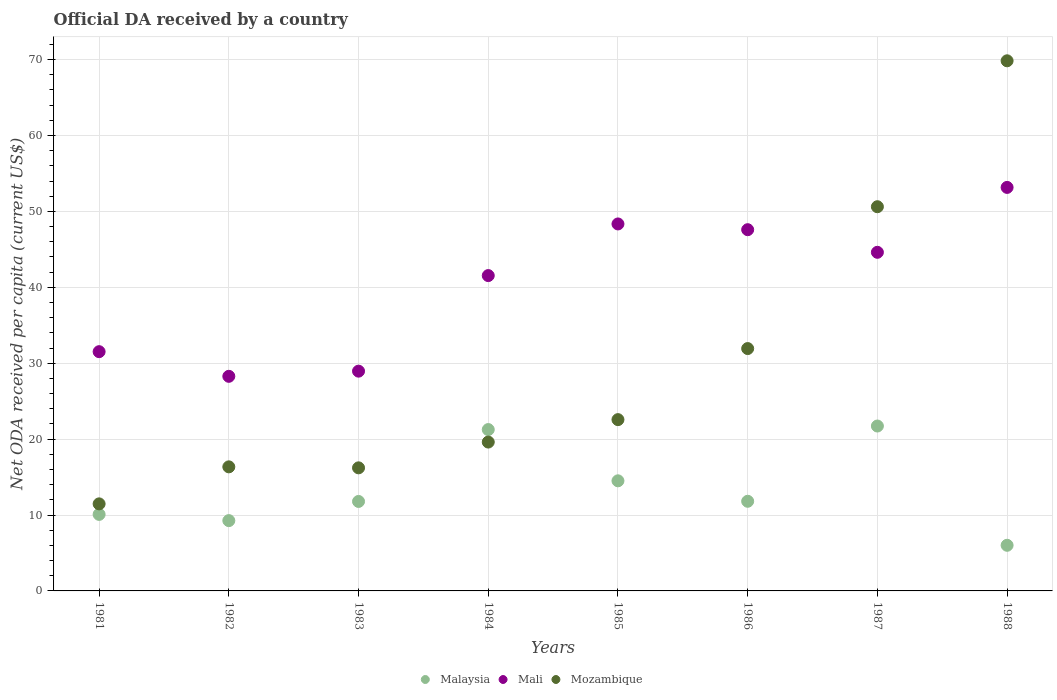Is the number of dotlines equal to the number of legend labels?
Your response must be concise. Yes. What is the ODA received in in Malaysia in 1985?
Ensure brevity in your answer.  14.51. Across all years, what is the maximum ODA received in in Mozambique?
Provide a short and direct response. 69.84. Across all years, what is the minimum ODA received in in Malaysia?
Keep it short and to the point. 6.01. What is the total ODA received in in Mozambique in the graph?
Provide a succinct answer. 238.59. What is the difference between the ODA received in in Malaysia in 1982 and that in 1987?
Provide a succinct answer. -12.46. What is the difference between the ODA received in in Mozambique in 1986 and the ODA received in in Mali in 1982?
Provide a succinct answer. 3.66. What is the average ODA received in in Malaysia per year?
Ensure brevity in your answer.  13.3. In the year 1988, what is the difference between the ODA received in in Mali and ODA received in in Malaysia?
Keep it short and to the point. 47.15. In how many years, is the ODA received in in Malaysia greater than 26 US$?
Your response must be concise. 0. What is the ratio of the ODA received in in Mali in 1982 to that in 1985?
Provide a succinct answer. 0.58. Is the difference between the ODA received in in Mali in 1982 and 1983 greater than the difference between the ODA received in in Malaysia in 1982 and 1983?
Make the answer very short. Yes. What is the difference between the highest and the second highest ODA received in in Malaysia?
Your response must be concise. 0.47. What is the difference between the highest and the lowest ODA received in in Malaysia?
Offer a very short reply. 15.71. In how many years, is the ODA received in in Mali greater than the average ODA received in in Mali taken over all years?
Keep it short and to the point. 5. Is it the case that in every year, the sum of the ODA received in in Mali and ODA received in in Mozambique  is greater than the ODA received in in Malaysia?
Make the answer very short. Yes. Is the ODA received in in Mozambique strictly greater than the ODA received in in Malaysia over the years?
Keep it short and to the point. No. Is the ODA received in in Mozambique strictly less than the ODA received in in Mali over the years?
Your answer should be compact. No. How many dotlines are there?
Keep it short and to the point. 3. Are the values on the major ticks of Y-axis written in scientific E-notation?
Provide a short and direct response. No. Where does the legend appear in the graph?
Provide a succinct answer. Bottom center. How many legend labels are there?
Provide a short and direct response. 3. What is the title of the graph?
Ensure brevity in your answer.  Official DA received by a country. Does "Greenland" appear as one of the legend labels in the graph?
Ensure brevity in your answer.  No. What is the label or title of the X-axis?
Give a very brief answer. Years. What is the label or title of the Y-axis?
Your answer should be very brief. Net ODA received per capita (current US$). What is the Net ODA received per capita (current US$) in Malaysia in 1981?
Your response must be concise. 10.08. What is the Net ODA received per capita (current US$) of Mali in 1981?
Make the answer very short. 31.52. What is the Net ODA received per capita (current US$) in Mozambique in 1981?
Give a very brief answer. 11.47. What is the Net ODA received per capita (current US$) in Malaysia in 1982?
Your answer should be compact. 9.26. What is the Net ODA received per capita (current US$) of Mali in 1982?
Keep it short and to the point. 28.27. What is the Net ODA received per capita (current US$) of Mozambique in 1982?
Give a very brief answer. 16.35. What is the Net ODA received per capita (current US$) of Malaysia in 1983?
Offer a terse response. 11.79. What is the Net ODA received per capita (current US$) of Mali in 1983?
Give a very brief answer. 28.95. What is the Net ODA received per capita (current US$) in Mozambique in 1983?
Make the answer very short. 16.21. What is the Net ODA received per capita (current US$) in Malaysia in 1984?
Ensure brevity in your answer.  21.26. What is the Net ODA received per capita (current US$) in Mali in 1984?
Make the answer very short. 41.54. What is the Net ODA received per capita (current US$) of Mozambique in 1984?
Keep it short and to the point. 19.61. What is the Net ODA received per capita (current US$) in Malaysia in 1985?
Your answer should be compact. 14.51. What is the Net ODA received per capita (current US$) of Mali in 1985?
Make the answer very short. 48.35. What is the Net ODA received per capita (current US$) in Mozambique in 1985?
Give a very brief answer. 22.57. What is the Net ODA received per capita (current US$) in Malaysia in 1986?
Provide a succinct answer. 11.81. What is the Net ODA received per capita (current US$) in Mali in 1986?
Your answer should be compact. 47.59. What is the Net ODA received per capita (current US$) in Mozambique in 1986?
Your answer should be compact. 31.93. What is the Net ODA received per capita (current US$) in Malaysia in 1987?
Make the answer very short. 21.72. What is the Net ODA received per capita (current US$) in Mali in 1987?
Make the answer very short. 44.61. What is the Net ODA received per capita (current US$) of Mozambique in 1987?
Give a very brief answer. 50.62. What is the Net ODA received per capita (current US$) of Malaysia in 1988?
Give a very brief answer. 6.01. What is the Net ODA received per capita (current US$) in Mali in 1988?
Ensure brevity in your answer.  53.16. What is the Net ODA received per capita (current US$) of Mozambique in 1988?
Provide a short and direct response. 69.84. Across all years, what is the maximum Net ODA received per capita (current US$) of Malaysia?
Offer a very short reply. 21.72. Across all years, what is the maximum Net ODA received per capita (current US$) in Mali?
Keep it short and to the point. 53.16. Across all years, what is the maximum Net ODA received per capita (current US$) in Mozambique?
Your answer should be very brief. 69.84. Across all years, what is the minimum Net ODA received per capita (current US$) of Malaysia?
Give a very brief answer. 6.01. Across all years, what is the minimum Net ODA received per capita (current US$) in Mali?
Ensure brevity in your answer.  28.27. Across all years, what is the minimum Net ODA received per capita (current US$) of Mozambique?
Make the answer very short. 11.47. What is the total Net ODA received per capita (current US$) of Malaysia in the graph?
Make the answer very short. 106.44. What is the total Net ODA received per capita (current US$) of Mali in the graph?
Provide a short and direct response. 324. What is the total Net ODA received per capita (current US$) in Mozambique in the graph?
Your response must be concise. 238.59. What is the difference between the Net ODA received per capita (current US$) of Malaysia in 1981 and that in 1982?
Provide a short and direct response. 0.82. What is the difference between the Net ODA received per capita (current US$) in Mali in 1981 and that in 1982?
Offer a very short reply. 3.25. What is the difference between the Net ODA received per capita (current US$) in Mozambique in 1981 and that in 1982?
Offer a terse response. -4.88. What is the difference between the Net ODA received per capita (current US$) in Malaysia in 1981 and that in 1983?
Provide a succinct answer. -1.71. What is the difference between the Net ODA received per capita (current US$) of Mali in 1981 and that in 1983?
Make the answer very short. 2.57. What is the difference between the Net ODA received per capita (current US$) in Mozambique in 1981 and that in 1983?
Your response must be concise. -4.75. What is the difference between the Net ODA received per capita (current US$) of Malaysia in 1981 and that in 1984?
Provide a succinct answer. -11.18. What is the difference between the Net ODA received per capita (current US$) in Mali in 1981 and that in 1984?
Offer a very short reply. -10.02. What is the difference between the Net ODA received per capita (current US$) in Mozambique in 1981 and that in 1984?
Keep it short and to the point. -8.14. What is the difference between the Net ODA received per capita (current US$) of Malaysia in 1981 and that in 1985?
Provide a succinct answer. -4.42. What is the difference between the Net ODA received per capita (current US$) in Mali in 1981 and that in 1985?
Make the answer very short. -16.83. What is the difference between the Net ODA received per capita (current US$) of Mozambique in 1981 and that in 1985?
Provide a succinct answer. -11.1. What is the difference between the Net ODA received per capita (current US$) in Malaysia in 1981 and that in 1986?
Provide a short and direct response. -1.73. What is the difference between the Net ODA received per capita (current US$) of Mali in 1981 and that in 1986?
Offer a terse response. -16.07. What is the difference between the Net ODA received per capita (current US$) of Mozambique in 1981 and that in 1986?
Offer a very short reply. -20.46. What is the difference between the Net ODA received per capita (current US$) in Malaysia in 1981 and that in 1987?
Keep it short and to the point. -11.64. What is the difference between the Net ODA received per capita (current US$) in Mali in 1981 and that in 1987?
Your answer should be compact. -13.09. What is the difference between the Net ODA received per capita (current US$) of Mozambique in 1981 and that in 1987?
Ensure brevity in your answer.  -39.15. What is the difference between the Net ODA received per capita (current US$) of Malaysia in 1981 and that in 1988?
Your answer should be compact. 4.07. What is the difference between the Net ODA received per capita (current US$) in Mali in 1981 and that in 1988?
Offer a terse response. -21.64. What is the difference between the Net ODA received per capita (current US$) in Mozambique in 1981 and that in 1988?
Your answer should be very brief. -58.37. What is the difference between the Net ODA received per capita (current US$) of Malaysia in 1982 and that in 1983?
Offer a very short reply. -2.52. What is the difference between the Net ODA received per capita (current US$) in Mali in 1982 and that in 1983?
Offer a terse response. -0.68. What is the difference between the Net ODA received per capita (current US$) in Mozambique in 1982 and that in 1983?
Your response must be concise. 0.13. What is the difference between the Net ODA received per capita (current US$) of Malaysia in 1982 and that in 1984?
Provide a succinct answer. -11.99. What is the difference between the Net ODA received per capita (current US$) in Mali in 1982 and that in 1984?
Your response must be concise. -13.27. What is the difference between the Net ODA received per capita (current US$) in Mozambique in 1982 and that in 1984?
Offer a terse response. -3.27. What is the difference between the Net ODA received per capita (current US$) of Malaysia in 1982 and that in 1985?
Make the answer very short. -5.24. What is the difference between the Net ODA received per capita (current US$) of Mali in 1982 and that in 1985?
Provide a short and direct response. -20.07. What is the difference between the Net ODA received per capita (current US$) of Mozambique in 1982 and that in 1985?
Give a very brief answer. -6.22. What is the difference between the Net ODA received per capita (current US$) of Malaysia in 1982 and that in 1986?
Ensure brevity in your answer.  -2.55. What is the difference between the Net ODA received per capita (current US$) in Mali in 1982 and that in 1986?
Your answer should be very brief. -19.32. What is the difference between the Net ODA received per capita (current US$) of Mozambique in 1982 and that in 1986?
Your answer should be compact. -15.58. What is the difference between the Net ODA received per capita (current US$) of Malaysia in 1982 and that in 1987?
Offer a very short reply. -12.46. What is the difference between the Net ODA received per capita (current US$) of Mali in 1982 and that in 1987?
Your response must be concise. -16.34. What is the difference between the Net ODA received per capita (current US$) of Mozambique in 1982 and that in 1987?
Provide a succinct answer. -34.27. What is the difference between the Net ODA received per capita (current US$) in Malaysia in 1982 and that in 1988?
Provide a short and direct response. 3.25. What is the difference between the Net ODA received per capita (current US$) of Mali in 1982 and that in 1988?
Your answer should be very brief. -24.89. What is the difference between the Net ODA received per capita (current US$) in Mozambique in 1982 and that in 1988?
Ensure brevity in your answer.  -53.49. What is the difference between the Net ODA received per capita (current US$) of Malaysia in 1983 and that in 1984?
Keep it short and to the point. -9.47. What is the difference between the Net ODA received per capita (current US$) in Mali in 1983 and that in 1984?
Offer a terse response. -12.59. What is the difference between the Net ODA received per capita (current US$) of Mozambique in 1983 and that in 1984?
Give a very brief answer. -3.4. What is the difference between the Net ODA received per capita (current US$) of Malaysia in 1983 and that in 1985?
Your answer should be compact. -2.72. What is the difference between the Net ODA received per capita (current US$) in Mali in 1983 and that in 1985?
Provide a succinct answer. -19.39. What is the difference between the Net ODA received per capita (current US$) of Mozambique in 1983 and that in 1985?
Make the answer very short. -6.35. What is the difference between the Net ODA received per capita (current US$) of Malaysia in 1983 and that in 1986?
Keep it short and to the point. -0.02. What is the difference between the Net ODA received per capita (current US$) of Mali in 1983 and that in 1986?
Keep it short and to the point. -18.64. What is the difference between the Net ODA received per capita (current US$) of Mozambique in 1983 and that in 1986?
Your answer should be compact. -15.71. What is the difference between the Net ODA received per capita (current US$) of Malaysia in 1983 and that in 1987?
Offer a very short reply. -9.94. What is the difference between the Net ODA received per capita (current US$) of Mali in 1983 and that in 1987?
Keep it short and to the point. -15.66. What is the difference between the Net ODA received per capita (current US$) in Mozambique in 1983 and that in 1987?
Provide a short and direct response. -34.4. What is the difference between the Net ODA received per capita (current US$) in Malaysia in 1983 and that in 1988?
Offer a terse response. 5.78. What is the difference between the Net ODA received per capita (current US$) of Mali in 1983 and that in 1988?
Offer a terse response. -24.21. What is the difference between the Net ODA received per capita (current US$) in Mozambique in 1983 and that in 1988?
Your answer should be very brief. -53.63. What is the difference between the Net ODA received per capita (current US$) of Malaysia in 1984 and that in 1985?
Your response must be concise. 6.75. What is the difference between the Net ODA received per capita (current US$) in Mali in 1984 and that in 1985?
Offer a terse response. -6.8. What is the difference between the Net ODA received per capita (current US$) in Mozambique in 1984 and that in 1985?
Your answer should be very brief. -2.96. What is the difference between the Net ODA received per capita (current US$) of Malaysia in 1984 and that in 1986?
Make the answer very short. 9.45. What is the difference between the Net ODA received per capita (current US$) of Mali in 1984 and that in 1986?
Provide a short and direct response. -6.05. What is the difference between the Net ODA received per capita (current US$) of Mozambique in 1984 and that in 1986?
Make the answer very short. -12.32. What is the difference between the Net ODA received per capita (current US$) of Malaysia in 1984 and that in 1987?
Make the answer very short. -0.47. What is the difference between the Net ODA received per capita (current US$) in Mali in 1984 and that in 1987?
Your response must be concise. -3.07. What is the difference between the Net ODA received per capita (current US$) of Mozambique in 1984 and that in 1987?
Your response must be concise. -31. What is the difference between the Net ODA received per capita (current US$) of Malaysia in 1984 and that in 1988?
Provide a short and direct response. 15.24. What is the difference between the Net ODA received per capita (current US$) of Mali in 1984 and that in 1988?
Your answer should be very brief. -11.62. What is the difference between the Net ODA received per capita (current US$) of Mozambique in 1984 and that in 1988?
Provide a short and direct response. -50.23. What is the difference between the Net ODA received per capita (current US$) of Malaysia in 1985 and that in 1986?
Ensure brevity in your answer.  2.7. What is the difference between the Net ODA received per capita (current US$) in Mali in 1985 and that in 1986?
Your response must be concise. 0.76. What is the difference between the Net ODA received per capita (current US$) of Mozambique in 1985 and that in 1986?
Your answer should be compact. -9.36. What is the difference between the Net ODA received per capita (current US$) of Malaysia in 1985 and that in 1987?
Keep it short and to the point. -7.22. What is the difference between the Net ODA received per capita (current US$) in Mali in 1985 and that in 1987?
Keep it short and to the point. 3.74. What is the difference between the Net ODA received per capita (current US$) of Mozambique in 1985 and that in 1987?
Ensure brevity in your answer.  -28.05. What is the difference between the Net ODA received per capita (current US$) in Malaysia in 1985 and that in 1988?
Offer a terse response. 8.49. What is the difference between the Net ODA received per capita (current US$) in Mali in 1985 and that in 1988?
Keep it short and to the point. -4.81. What is the difference between the Net ODA received per capita (current US$) of Mozambique in 1985 and that in 1988?
Offer a very short reply. -47.27. What is the difference between the Net ODA received per capita (current US$) in Malaysia in 1986 and that in 1987?
Offer a terse response. -9.91. What is the difference between the Net ODA received per capita (current US$) of Mali in 1986 and that in 1987?
Make the answer very short. 2.98. What is the difference between the Net ODA received per capita (current US$) of Mozambique in 1986 and that in 1987?
Provide a short and direct response. -18.69. What is the difference between the Net ODA received per capita (current US$) in Malaysia in 1986 and that in 1988?
Provide a succinct answer. 5.8. What is the difference between the Net ODA received per capita (current US$) in Mali in 1986 and that in 1988?
Ensure brevity in your answer.  -5.57. What is the difference between the Net ODA received per capita (current US$) of Mozambique in 1986 and that in 1988?
Ensure brevity in your answer.  -37.91. What is the difference between the Net ODA received per capita (current US$) in Malaysia in 1987 and that in 1988?
Your answer should be compact. 15.71. What is the difference between the Net ODA received per capita (current US$) in Mali in 1987 and that in 1988?
Give a very brief answer. -8.55. What is the difference between the Net ODA received per capita (current US$) of Mozambique in 1987 and that in 1988?
Provide a short and direct response. -19.22. What is the difference between the Net ODA received per capita (current US$) of Malaysia in 1981 and the Net ODA received per capita (current US$) of Mali in 1982?
Keep it short and to the point. -18.19. What is the difference between the Net ODA received per capita (current US$) of Malaysia in 1981 and the Net ODA received per capita (current US$) of Mozambique in 1982?
Make the answer very short. -6.26. What is the difference between the Net ODA received per capita (current US$) of Mali in 1981 and the Net ODA received per capita (current US$) of Mozambique in 1982?
Offer a very short reply. 15.17. What is the difference between the Net ODA received per capita (current US$) of Malaysia in 1981 and the Net ODA received per capita (current US$) of Mali in 1983?
Provide a succinct answer. -18.87. What is the difference between the Net ODA received per capita (current US$) in Malaysia in 1981 and the Net ODA received per capita (current US$) in Mozambique in 1983?
Your answer should be compact. -6.13. What is the difference between the Net ODA received per capita (current US$) in Mali in 1981 and the Net ODA received per capita (current US$) in Mozambique in 1983?
Provide a short and direct response. 15.31. What is the difference between the Net ODA received per capita (current US$) in Malaysia in 1981 and the Net ODA received per capita (current US$) in Mali in 1984?
Ensure brevity in your answer.  -31.46. What is the difference between the Net ODA received per capita (current US$) in Malaysia in 1981 and the Net ODA received per capita (current US$) in Mozambique in 1984?
Your answer should be very brief. -9.53. What is the difference between the Net ODA received per capita (current US$) in Mali in 1981 and the Net ODA received per capita (current US$) in Mozambique in 1984?
Your answer should be very brief. 11.91. What is the difference between the Net ODA received per capita (current US$) of Malaysia in 1981 and the Net ODA received per capita (current US$) of Mali in 1985?
Make the answer very short. -38.27. What is the difference between the Net ODA received per capita (current US$) of Malaysia in 1981 and the Net ODA received per capita (current US$) of Mozambique in 1985?
Give a very brief answer. -12.48. What is the difference between the Net ODA received per capita (current US$) of Mali in 1981 and the Net ODA received per capita (current US$) of Mozambique in 1985?
Offer a very short reply. 8.95. What is the difference between the Net ODA received per capita (current US$) in Malaysia in 1981 and the Net ODA received per capita (current US$) in Mali in 1986?
Your answer should be very brief. -37.51. What is the difference between the Net ODA received per capita (current US$) in Malaysia in 1981 and the Net ODA received per capita (current US$) in Mozambique in 1986?
Your response must be concise. -21.85. What is the difference between the Net ODA received per capita (current US$) of Mali in 1981 and the Net ODA received per capita (current US$) of Mozambique in 1986?
Offer a terse response. -0.41. What is the difference between the Net ODA received per capita (current US$) in Malaysia in 1981 and the Net ODA received per capita (current US$) in Mali in 1987?
Provide a short and direct response. -34.53. What is the difference between the Net ODA received per capita (current US$) of Malaysia in 1981 and the Net ODA received per capita (current US$) of Mozambique in 1987?
Offer a very short reply. -40.53. What is the difference between the Net ODA received per capita (current US$) of Mali in 1981 and the Net ODA received per capita (current US$) of Mozambique in 1987?
Your answer should be very brief. -19.1. What is the difference between the Net ODA received per capita (current US$) of Malaysia in 1981 and the Net ODA received per capita (current US$) of Mali in 1988?
Make the answer very short. -43.08. What is the difference between the Net ODA received per capita (current US$) in Malaysia in 1981 and the Net ODA received per capita (current US$) in Mozambique in 1988?
Your answer should be compact. -59.76. What is the difference between the Net ODA received per capita (current US$) of Mali in 1981 and the Net ODA received per capita (current US$) of Mozambique in 1988?
Offer a very short reply. -38.32. What is the difference between the Net ODA received per capita (current US$) in Malaysia in 1982 and the Net ODA received per capita (current US$) in Mali in 1983?
Your answer should be very brief. -19.69. What is the difference between the Net ODA received per capita (current US$) in Malaysia in 1982 and the Net ODA received per capita (current US$) in Mozambique in 1983?
Keep it short and to the point. -6.95. What is the difference between the Net ODA received per capita (current US$) of Mali in 1982 and the Net ODA received per capita (current US$) of Mozambique in 1983?
Your response must be concise. 12.06. What is the difference between the Net ODA received per capita (current US$) of Malaysia in 1982 and the Net ODA received per capita (current US$) of Mali in 1984?
Your response must be concise. -32.28. What is the difference between the Net ODA received per capita (current US$) of Malaysia in 1982 and the Net ODA received per capita (current US$) of Mozambique in 1984?
Give a very brief answer. -10.35. What is the difference between the Net ODA received per capita (current US$) in Mali in 1982 and the Net ODA received per capita (current US$) in Mozambique in 1984?
Ensure brevity in your answer.  8.66. What is the difference between the Net ODA received per capita (current US$) in Malaysia in 1982 and the Net ODA received per capita (current US$) in Mali in 1985?
Offer a terse response. -39.08. What is the difference between the Net ODA received per capita (current US$) of Malaysia in 1982 and the Net ODA received per capita (current US$) of Mozambique in 1985?
Offer a very short reply. -13.3. What is the difference between the Net ODA received per capita (current US$) of Mali in 1982 and the Net ODA received per capita (current US$) of Mozambique in 1985?
Your answer should be compact. 5.71. What is the difference between the Net ODA received per capita (current US$) of Malaysia in 1982 and the Net ODA received per capita (current US$) of Mali in 1986?
Offer a very short reply. -38.33. What is the difference between the Net ODA received per capita (current US$) in Malaysia in 1982 and the Net ODA received per capita (current US$) in Mozambique in 1986?
Ensure brevity in your answer.  -22.67. What is the difference between the Net ODA received per capita (current US$) of Mali in 1982 and the Net ODA received per capita (current US$) of Mozambique in 1986?
Provide a short and direct response. -3.66. What is the difference between the Net ODA received per capita (current US$) in Malaysia in 1982 and the Net ODA received per capita (current US$) in Mali in 1987?
Provide a short and direct response. -35.35. What is the difference between the Net ODA received per capita (current US$) in Malaysia in 1982 and the Net ODA received per capita (current US$) in Mozambique in 1987?
Your response must be concise. -41.35. What is the difference between the Net ODA received per capita (current US$) in Mali in 1982 and the Net ODA received per capita (current US$) in Mozambique in 1987?
Your answer should be compact. -22.34. What is the difference between the Net ODA received per capita (current US$) in Malaysia in 1982 and the Net ODA received per capita (current US$) in Mali in 1988?
Provide a short and direct response. -43.9. What is the difference between the Net ODA received per capita (current US$) in Malaysia in 1982 and the Net ODA received per capita (current US$) in Mozambique in 1988?
Ensure brevity in your answer.  -60.58. What is the difference between the Net ODA received per capita (current US$) of Mali in 1982 and the Net ODA received per capita (current US$) of Mozambique in 1988?
Provide a short and direct response. -41.57. What is the difference between the Net ODA received per capita (current US$) of Malaysia in 1983 and the Net ODA received per capita (current US$) of Mali in 1984?
Your answer should be compact. -29.76. What is the difference between the Net ODA received per capita (current US$) in Malaysia in 1983 and the Net ODA received per capita (current US$) in Mozambique in 1984?
Offer a very short reply. -7.82. What is the difference between the Net ODA received per capita (current US$) in Mali in 1983 and the Net ODA received per capita (current US$) in Mozambique in 1984?
Your answer should be very brief. 9.34. What is the difference between the Net ODA received per capita (current US$) of Malaysia in 1983 and the Net ODA received per capita (current US$) of Mali in 1985?
Provide a short and direct response. -36.56. What is the difference between the Net ODA received per capita (current US$) in Malaysia in 1983 and the Net ODA received per capita (current US$) in Mozambique in 1985?
Keep it short and to the point. -10.78. What is the difference between the Net ODA received per capita (current US$) in Mali in 1983 and the Net ODA received per capita (current US$) in Mozambique in 1985?
Your answer should be compact. 6.39. What is the difference between the Net ODA received per capita (current US$) of Malaysia in 1983 and the Net ODA received per capita (current US$) of Mali in 1986?
Offer a terse response. -35.8. What is the difference between the Net ODA received per capita (current US$) of Malaysia in 1983 and the Net ODA received per capita (current US$) of Mozambique in 1986?
Make the answer very short. -20.14. What is the difference between the Net ODA received per capita (current US$) in Mali in 1983 and the Net ODA received per capita (current US$) in Mozambique in 1986?
Make the answer very short. -2.98. What is the difference between the Net ODA received per capita (current US$) in Malaysia in 1983 and the Net ODA received per capita (current US$) in Mali in 1987?
Offer a very short reply. -32.82. What is the difference between the Net ODA received per capita (current US$) of Malaysia in 1983 and the Net ODA received per capita (current US$) of Mozambique in 1987?
Provide a short and direct response. -38.83. What is the difference between the Net ODA received per capita (current US$) of Mali in 1983 and the Net ODA received per capita (current US$) of Mozambique in 1987?
Offer a very short reply. -21.66. What is the difference between the Net ODA received per capita (current US$) in Malaysia in 1983 and the Net ODA received per capita (current US$) in Mali in 1988?
Ensure brevity in your answer.  -41.37. What is the difference between the Net ODA received per capita (current US$) in Malaysia in 1983 and the Net ODA received per capita (current US$) in Mozambique in 1988?
Your answer should be compact. -58.05. What is the difference between the Net ODA received per capita (current US$) in Mali in 1983 and the Net ODA received per capita (current US$) in Mozambique in 1988?
Offer a very short reply. -40.89. What is the difference between the Net ODA received per capita (current US$) of Malaysia in 1984 and the Net ODA received per capita (current US$) of Mali in 1985?
Ensure brevity in your answer.  -27.09. What is the difference between the Net ODA received per capita (current US$) in Malaysia in 1984 and the Net ODA received per capita (current US$) in Mozambique in 1985?
Ensure brevity in your answer.  -1.31. What is the difference between the Net ODA received per capita (current US$) of Mali in 1984 and the Net ODA received per capita (current US$) of Mozambique in 1985?
Your response must be concise. 18.98. What is the difference between the Net ODA received per capita (current US$) of Malaysia in 1984 and the Net ODA received per capita (current US$) of Mali in 1986?
Provide a short and direct response. -26.33. What is the difference between the Net ODA received per capita (current US$) of Malaysia in 1984 and the Net ODA received per capita (current US$) of Mozambique in 1986?
Ensure brevity in your answer.  -10.67. What is the difference between the Net ODA received per capita (current US$) in Mali in 1984 and the Net ODA received per capita (current US$) in Mozambique in 1986?
Offer a very short reply. 9.61. What is the difference between the Net ODA received per capita (current US$) of Malaysia in 1984 and the Net ODA received per capita (current US$) of Mali in 1987?
Provide a short and direct response. -23.35. What is the difference between the Net ODA received per capita (current US$) of Malaysia in 1984 and the Net ODA received per capita (current US$) of Mozambique in 1987?
Your response must be concise. -29.36. What is the difference between the Net ODA received per capita (current US$) in Mali in 1984 and the Net ODA received per capita (current US$) in Mozambique in 1987?
Your answer should be compact. -9.07. What is the difference between the Net ODA received per capita (current US$) of Malaysia in 1984 and the Net ODA received per capita (current US$) of Mali in 1988?
Provide a succinct answer. -31.9. What is the difference between the Net ODA received per capita (current US$) of Malaysia in 1984 and the Net ODA received per capita (current US$) of Mozambique in 1988?
Make the answer very short. -48.58. What is the difference between the Net ODA received per capita (current US$) of Mali in 1984 and the Net ODA received per capita (current US$) of Mozambique in 1988?
Ensure brevity in your answer.  -28.3. What is the difference between the Net ODA received per capita (current US$) of Malaysia in 1985 and the Net ODA received per capita (current US$) of Mali in 1986?
Your answer should be compact. -33.08. What is the difference between the Net ODA received per capita (current US$) in Malaysia in 1985 and the Net ODA received per capita (current US$) in Mozambique in 1986?
Your answer should be compact. -17.42. What is the difference between the Net ODA received per capita (current US$) in Mali in 1985 and the Net ODA received per capita (current US$) in Mozambique in 1986?
Provide a short and direct response. 16.42. What is the difference between the Net ODA received per capita (current US$) of Malaysia in 1985 and the Net ODA received per capita (current US$) of Mali in 1987?
Provide a succinct answer. -30.11. What is the difference between the Net ODA received per capita (current US$) in Malaysia in 1985 and the Net ODA received per capita (current US$) in Mozambique in 1987?
Provide a short and direct response. -36.11. What is the difference between the Net ODA received per capita (current US$) in Mali in 1985 and the Net ODA received per capita (current US$) in Mozambique in 1987?
Give a very brief answer. -2.27. What is the difference between the Net ODA received per capita (current US$) of Malaysia in 1985 and the Net ODA received per capita (current US$) of Mali in 1988?
Provide a short and direct response. -38.65. What is the difference between the Net ODA received per capita (current US$) in Malaysia in 1985 and the Net ODA received per capita (current US$) in Mozambique in 1988?
Keep it short and to the point. -55.33. What is the difference between the Net ODA received per capita (current US$) in Mali in 1985 and the Net ODA received per capita (current US$) in Mozambique in 1988?
Provide a short and direct response. -21.49. What is the difference between the Net ODA received per capita (current US$) in Malaysia in 1986 and the Net ODA received per capita (current US$) in Mali in 1987?
Your answer should be compact. -32.8. What is the difference between the Net ODA received per capita (current US$) in Malaysia in 1986 and the Net ODA received per capita (current US$) in Mozambique in 1987?
Provide a short and direct response. -38.81. What is the difference between the Net ODA received per capita (current US$) of Mali in 1986 and the Net ODA received per capita (current US$) of Mozambique in 1987?
Make the answer very short. -3.03. What is the difference between the Net ODA received per capita (current US$) of Malaysia in 1986 and the Net ODA received per capita (current US$) of Mali in 1988?
Make the answer very short. -41.35. What is the difference between the Net ODA received per capita (current US$) in Malaysia in 1986 and the Net ODA received per capita (current US$) in Mozambique in 1988?
Give a very brief answer. -58.03. What is the difference between the Net ODA received per capita (current US$) in Mali in 1986 and the Net ODA received per capita (current US$) in Mozambique in 1988?
Make the answer very short. -22.25. What is the difference between the Net ODA received per capita (current US$) in Malaysia in 1987 and the Net ODA received per capita (current US$) in Mali in 1988?
Give a very brief answer. -31.44. What is the difference between the Net ODA received per capita (current US$) of Malaysia in 1987 and the Net ODA received per capita (current US$) of Mozambique in 1988?
Your answer should be compact. -48.12. What is the difference between the Net ODA received per capita (current US$) in Mali in 1987 and the Net ODA received per capita (current US$) in Mozambique in 1988?
Ensure brevity in your answer.  -25.23. What is the average Net ODA received per capita (current US$) in Malaysia per year?
Your response must be concise. 13.3. What is the average Net ODA received per capita (current US$) of Mali per year?
Your answer should be compact. 40.5. What is the average Net ODA received per capita (current US$) of Mozambique per year?
Provide a short and direct response. 29.82. In the year 1981, what is the difference between the Net ODA received per capita (current US$) of Malaysia and Net ODA received per capita (current US$) of Mali?
Ensure brevity in your answer.  -21.44. In the year 1981, what is the difference between the Net ODA received per capita (current US$) in Malaysia and Net ODA received per capita (current US$) in Mozambique?
Ensure brevity in your answer.  -1.39. In the year 1981, what is the difference between the Net ODA received per capita (current US$) of Mali and Net ODA received per capita (current US$) of Mozambique?
Offer a terse response. 20.05. In the year 1982, what is the difference between the Net ODA received per capita (current US$) of Malaysia and Net ODA received per capita (current US$) of Mali?
Keep it short and to the point. -19.01. In the year 1982, what is the difference between the Net ODA received per capita (current US$) in Malaysia and Net ODA received per capita (current US$) in Mozambique?
Provide a succinct answer. -7.08. In the year 1982, what is the difference between the Net ODA received per capita (current US$) in Mali and Net ODA received per capita (current US$) in Mozambique?
Make the answer very short. 11.93. In the year 1983, what is the difference between the Net ODA received per capita (current US$) of Malaysia and Net ODA received per capita (current US$) of Mali?
Make the answer very short. -17.16. In the year 1983, what is the difference between the Net ODA received per capita (current US$) of Malaysia and Net ODA received per capita (current US$) of Mozambique?
Ensure brevity in your answer.  -4.43. In the year 1983, what is the difference between the Net ODA received per capita (current US$) of Mali and Net ODA received per capita (current US$) of Mozambique?
Your answer should be compact. 12.74. In the year 1984, what is the difference between the Net ODA received per capita (current US$) of Malaysia and Net ODA received per capita (current US$) of Mali?
Your answer should be very brief. -20.29. In the year 1984, what is the difference between the Net ODA received per capita (current US$) of Malaysia and Net ODA received per capita (current US$) of Mozambique?
Keep it short and to the point. 1.65. In the year 1984, what is the difference between the Net ODA received per capita (current US$) of Mali and Net ODA received per capita (current US$) of Mozambique?
Offer a terse response. 21.93. In the year 1985, what is the difference between the Net ODA received per capita (current US$) in Malaysia and Net ODA received per capita (current US$) in Mali?
Keep it short and to the point. -33.84. In the year 1985, what is the difference between the Net ODA received per capita (current US$) of Malaysia and Net ODA received per capita (current US$) of Mozambique?
Keep it short and to the point. -8.06. In the year 1985, what is the difference between the Net ODA received per capita (current US$) of Mali and Net ODA received per capita (current US$) of Mozambique?
Give a very brief answer. 25.78. In the year 1986, what is the difference between the Net ODA received per capita (current US$) in Malaysia and Net ODA received per capita (current US$) in Mali?
Provide a succinct answer. -35.78. In the year 1986, what is the difference between the Net ODA received per capita (current US$) in Malaysia and Net ODA received per capita (current US$) in Mozambique?
Your answer should be compact. -20.12. In the year 1986, what is the difference between the Net ODA received per capita (current US$) of Mali and Net ODA received per capita (current US$) of Mozambique?
Offer a terse response. 15.66. In the year 1987, what is the difference between the Net ODA received per capita (current US$) of Malaysia and Net ODA received per capita (current US$) of Mali?
Make the answer very short. -22.89. In the year 1987, what is the difference between the Net ODA received per capita (current US$) of Malaysia and Net ODA received per capita (current US$) of Mozambique?
Provide a succinct answer. -28.89. In the year 1987, what is the difference between the Net ODA received per capita (current US$) of Mali and Net ODA received per capita (current US$) of Mozambique?
Provide a succinct answer. -6. In the year 1988, what is the difference between the Net ODA received per capita (current US$) in Malaysia and Net ODA received per capita (current US$) in Mali?
Keep it short and to the point. -47.15. In the year 1988, what is the difference between the Net ODA received per capita (current US$) of Malaysia and Net ODA received per capita (current US$) of Mozambique?
Make the answer very short. -63.83. In the year 1988, what is the difference between the Net ODA received per capita (current US$) of Mali and Net ODA received per capita (current US$) of Mozambique?
Give a very brief answer. -16.68. What is the ratio of the Net ODA received per capita (current US$) of Malaysia in 1981 to that in 1982?
Offer a very short reply. 1.09. What is the ratio of the Net ODA received per capita (current US$) of Mali in 1981 to that in 1982?
Your response must be concise. 1.11. What is the ratio of the Net ODA received per capita (current US$) of Mozambique in 1981 to that in 1982?
Offer a terse response. 0.7. What is the ratio of the Net ODA received per capita (current US$) in Malaysia in 1981 to that in 1983?
Provide a short and direct response. 0.86. What is the ratio of the Net ODA received per capita (current US$) of Mali in 1981 to that in 1983?
Offer a terse response. 1.09. What is the ratio of the Net ODA received per capita (current US$) in Mozambique in 1981 to that in 1983?
Your answer should be compact. 0.71. What is the ratio of the Net ODA received per capita (current US$) of Malaysia in 1981 to that in 1984?
Make the answer very short. 0.47. What is the ratio of the Net ODA received per capita (current US$) in Mali in 1981 to that in 1984?
Keep it short and to the point. 0.76. What is the ratio of the Net ODA received per capita (current US$) in Mozambique in 1981 to that in 1984?
Provide a succinct answer. 0.58. What is the ratio of the Net ODA received per capita (current US$) in Malaysia in 1981 to that in 1985?
Provide a succinct answer. 0.69. What is the ratio of the Net ODA received per capita (current US$) in Mali in 1981 to that in 1985?
Give a very brief answer. 0.65. What is the ratio of the Net ODA received per capita (current US$) in Mozambique in 1981 to that in 1985?
Make the answer very short. 0.51. What is the ratio of the Net ODA received per capita (current US$) of Malaysia in 1981 to that in 1986?
Offer a very short reply. 0.85. What is the ratio of the Net ODA received per capita (current US$) in Mali in 1981 to that in 1986?
Provide a succinct answer. 0.66. What is the ratio of the Net ODA received per capita (current US$) of Mozambique in 1981 to that in 1986?
Offer a terse response. 0.36. What is the ratio of the Net ODA received per capita (current US$) in Malaysia in 1981 to that in 1987?
Your response must be concise. 0.46. What is the ratio of the Net ODA received per capita (current US$) of Mali in 1981 to that in 1987?
Offer a terse response. 0.71. What is the ratio of the Net ODA received per capita (current US$) of Mozambique in 1981 to that in 1987?
Offer a very short reply. 0.23. What is the ratio of the Net ODA received per capita (current US$) of Malaysia in 1981 to that in 1988?
Give a very brief answer. 1.68. What is the ratio of the Net ODA received per capita (current US$) of Mali in 1981 to that in 1988?
Your answer should be compact. 0.59. What is the ratio of the Net ODA received per capita (current US$) in Mozambique in 1981 to that in 1988?
Your answer should be very brief. 0.16. What is the ratio of the Net ODA received per capita (current US$) of Malaysia in 1982 to that in 1983?
Make the answer very short. 0.79. What is the ratio of the Net ODA received per capita (current US$) in Mali in 1982 to that in 1983?
Offer a terse response. 0.98. What is the ratio of the Net ODA received per capita (current US$) of Malaysia in 1982 to that in 1984?
Give a very brief answer. 0.44. What is the ratio of the Net ODA received per capita (current US$) of Mali in 1982 to that in 1984?
Give a very brief answer. 0.68. What is the ratio of the Net ODA received per capita (current US$) of Mozambique in 1982 to that in 1984?
Ensure brevity in your answer.  0.83. What is the ratio of the Net ODA received per capita (current US$) of Malaysia in 1982 to that in 1985?
Give a very brief answer. 0.64. What is the ratio of the Net ODA received per capita (current US$) in Mali in 1982 to that in 1985?
Offer a terse response. 0.58. What is the ratio of the Net ODA received per capita (current US$) of Mozambique in 1982 to that in 1985?
Make the answer very short. 0.72. What is the ratio of the Net ODA received per capita (current US$) in Malaysia in 1982 to that in 1986?
Make the answer very short. 0.78. What is the ratio of the Net ODA received per capita (current US$) in Mali in 1982 to that in 1986?
Ensure brevity in your answer.  0.59. What is the ratio of the Net ODA received per capita (current US$) in Mozambique in 1982 to that in 1986?
Your answer should be compact. 0.51. What is the ratio of the Net ODA received per capita (current US$) in Malaysia in 1982 to that in 1987?
Provide a short and direct response. 0.43. What is the ratio of the Net ODA received per capita (current US$) of Mali in 1982 to that in 1987?
Offer a very short reply. 0.63. What is the ratio of the Net ODA received per capita (current US$) of Mozambique in 1982 to that in 1987?
Ensure brevity in your answer.  0.32. What is the ratio of the Net ODA received per capita (current US$) in Malaysia in 1982 to that in 1988?
Your answer should be very brief. 1.54. What is the ratio of the Net ODA received per capita (current US$) in Mali in 1982 to that in 1988?
Keep it short and to the point. 0.53. What is the ratio of the Net ODA received per capita (current US$) of Mozambique in 1982 to that in 1988?
Provide a succinct answer. 0.23. What is the ratio of the Net ODA received per capita (current US$) in Malaysia in 1983 to that in 1984?
Keep it short and to the point. 0.55. What is the ratio of the Net ODA received per capita (current US$) of Mali in 1983 to that in 1984?
Your answer should be very brief. 0.7. What is the ratio of the Net ODA received per capita (current US$) in Mozambique in 1983 to that in 1984?
Your response must be concise. 0.83. What is the ratio of the Net ODA received per capita (current US$) of Malaysia in 1983 to that in 1985?
Ensure brevity in your answer.  0.81. What is the ratio of the Net ODA received per capita (current US$) of Mali in 1983 to that in 1985?
Give a very brief answer. 0.6. What is the ratio of the Net ODA received per capita (current US$) in Mozambique in 1983 to that in 1985?
Offer a very short reply. 0.72. What is the ratio of the Net ODA received per capita (current US$) of Mali in 1983 to that in 1986?
Make the answer very short. 0.61. What is the ratio of the Net ODA received per capita (current US$) in Mozambique in 1983 to that in 1986?
Give a very brief answer. 0.51. What is the ratio of the Net ODA received per capita (current US$) of Malaysia in 1983 to that in 1987?
Give a very brief answer. 0.54. What is the ratio of the Net ODA received per capita (current US$) of Mali in 1983 to that in 1987?
Offer a terse response. 0.65. What is the ratio of the Net ODA received per capita (current US$) in Mozambique in 1983 to that in 1987?
Your answer should be compact. 0.32. What is the ratio of the Net ODA received per capita (current US$) of Malaysia in 1983 to that in 1988?
Provide a short and direct response. 1.96. What is the ratio of the Net ODA received per capita (current US$) of Mali in 1983 to that in 1988?
Your answer should be very brief. 0.54. What is the ratio of the Net ODA received per capita (current US$) of Mozambique in 1983 to that in 1988?
Give a very brief answer. 0.23. What is the ratio of the Net ODA received per capita (current US$) of Malaysia in 1984 to that in 1985?
Your answer should be compact. 1.47. What is the ratio of the Net ODA received per capita (current US$) of Mali in 1984 to that in 1985?
Make the answer very short. 0.86. What is the ratio of the Net ODA received per capita (current US$) of Mozambique in 1984 to that in 1985?
Your answer should be compact. 0.87. What is the ratio of the Net ODA received per capita (current US$) in Malaysia in 1984 to that in 1986?
Offer a terse response. 1.8. What is the ratio of the Net ODA received per capita (current US$) of Mali in 1984 to that in 1986?
Your answer should be very brief. 0.87. What is the ratio of the Net ODA received per capita (current US$) of Mozambique in 1984 to that in 1986?
Your answer should be very brief. 0.61. What is the ratio of the Net ODA received per capita (current US$) in Malaysia in 1984 to that in 1987?
Your answer should be compact. 0.98. What is the ratio of the Net ODA received per capita (current US$) of Mali in 1984 to that in 1987?
Provide a succinct answer. 0.93. What is the ratio of the Net ODA received per capita (current US$) of Mozambique in 1984 to that in 1987?
Offer a very short reply. 0.39. What is the ratio of the Net ODA received per capita (current US$) of Malaysia in 1984 to that in 1988?
Provide a succinct answer. 3.54. What is the ratio of the Net ODA received per capita (current US$) in Mali in 1984 to that in 1988?
Offer a very short reply. 0.78. What is the ratio of the Net ODA received per capita (current US$) of Mozambique in 1984 to that in 1988?
Make the answer very short. 0.28. What is the ratio of the Net ODA received per capita (current US$) in Malaysia in 1985 to that in 1986?
Give a very brief answer. 1.23. What is the ratio of the Net ODA received per capita (current US$) of Mali in 1985 to that in 1986?
Provide a short and direct response. 1.02. What is the ratio of the Net ODA received per capita (current US$) in Mozambique in 1985 to that in 1986?
Give a very brief answer. 0.71. What is the ratio of the Net ODA received per capita (current US$) in Malaysia in 1985 to that in 1987?
Make the answer very short. 0.67. What is the ratio of the Net ODA received per capita (current US$) of Mali in 1985 to that in 1987?
Your answer should be very brief. 1.08. What is the ratio of the Net ODA received per capita (current US$) in Mozambique in 1985 to that in 1987?
Provide a short and direct response. 0.45. What is the ratio of the Net ODA received per capita (current US$) of Malaysia in 1985 to that in 1988?
Provide a succinct answer. 2.41. What is the ratio of the Net ODA received per capita (current US$) of Mali in 1985 to that in 1988?
Make the answer very short. 0.91. What is the ratio of the Net ODA received per capita (current US$) in Mozambique in 1985 to that in 1988?
Offer a very short reply. 0.32. What is the ratio of the Net ODA received per capita (current US$) of Malaysia in 1986 to that in 1987?
Your answer should be very brief. 0.54. What is the ratio of the Net ODA received per capita (current US$) in Mali in 1986 to that in 1987?
Your answer should be compact. 1.07. What is the ratio of the Net ODA received per capita (current US$) in Mozambique in 1986 to that in 1987?
Offer a very short reply. 0.63. What is the ratio of the Net ODA received per capita (current US$) of Malaysia in 1986 to that in 1988?
Keep it short and to the point. 1.96. What is the ratio of the Net ODA received per capita (current US$) in Mali in 1986 to that in 1988?
Offer a terse response. 0.9. What is the ratio of the Net ODA received per capita (current US$) in Mozambique in 1986 to that in 1988?
Give a very brief answer. 0.46. What is the ratio of the Net ODA received per capita (current US$) of Malaysia in 1987 to that in 1988?
Keep it short and to the point. 3.61. What is the ratio of the Net ODA received per capita (current US$) in Mali in 1987 to that in 1988?
Keep it short and to the point. 0.84. What is the ratio of the Net ODA received per capita (current US$) of Mozambique in 1987 to that in 1988?
Ensure brevity in your answer.  0.72. What is the difference between the highest and the second highest Net ODA received per capita (current US$) in Malaysia?
Your response must be concise. 0.47. What is the difference between the highest and the second highest Net ODA received per capita (current US$) in Mali?
Your answer should be very brief. 4.81. What is the difference between the highest and the second highest Net ODA received per capita (current US$) in Mozambique?
Keep it short and to the point. 19.22. What is the difference between the highest and the lowest Net ODA received per capita (current US$) of Malaysia?
Keep it short and to the point. 15.71. What is the difference between the highest and the lowest Net ODA received per capita (current US$) in Mali?
Provide a short and direct response. 24.89. What is the difference between the highest and the lowest Net ODA received per capita (current US$) in Mozambique?
Your answer should be very brief. 58.37. 